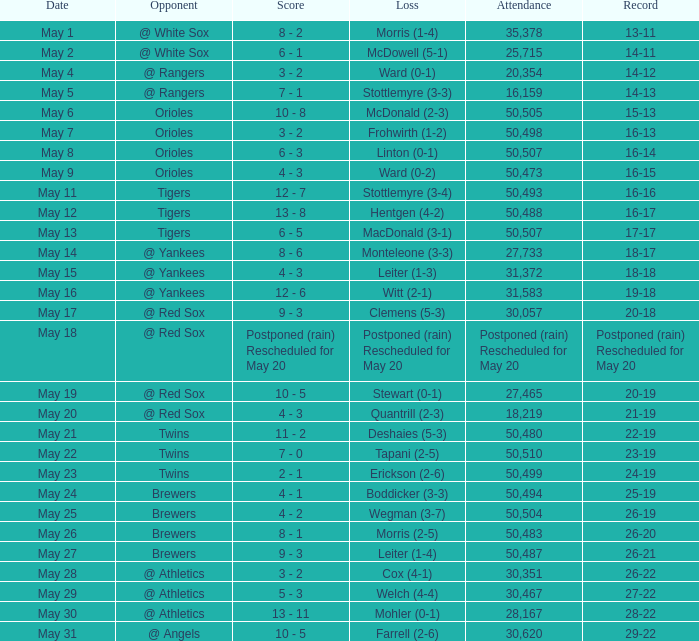To which team did they suffer a loss when their standing was at 28-22? Mohler (0-1). 